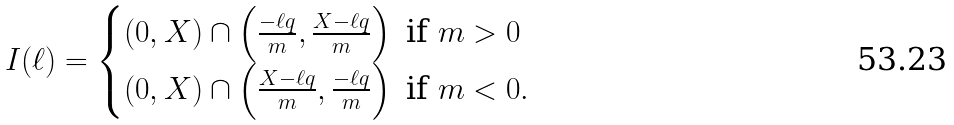Convert formula to latex. <formula><loc_0><loc_0><loc_500><loc_500>I ( \ell ) = \begin{cases} ( 0 , X ) \cap \left ( \frac { - \ell q } { m } , \frac { X - \ell q } { m } \right ) \text { if } m > 0 \\ ( 0 , X ) \cap \left ( \frac { X - \ell q } { m } , \frac { - \ell q } { m } \right ) \text { if } m < 0 . \end{cases}</formula> 